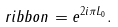<formula> <loc_0><loc_0><loc_500><loc_500>\ r i b b o n = e ^ { 2 i \pi L _ { 0 } } .</formula> 